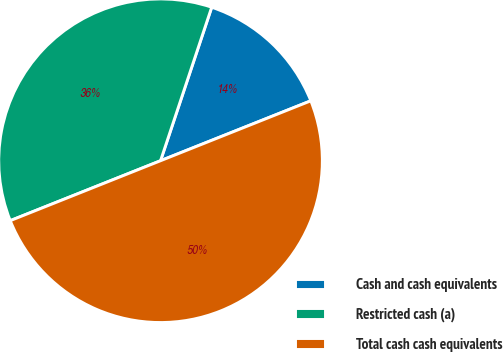Convert chart to OTSL. <chart><loc_0><loc_0><loc_500><loc_500><pie_chart><fcel>Cash and cash equivalents<fcel>Restricted cash (a)<fcel>Total cash cash equivalents<nl><fcel>13.84%<fcel>36.16%<fcel>50.0%<nl></chart> 